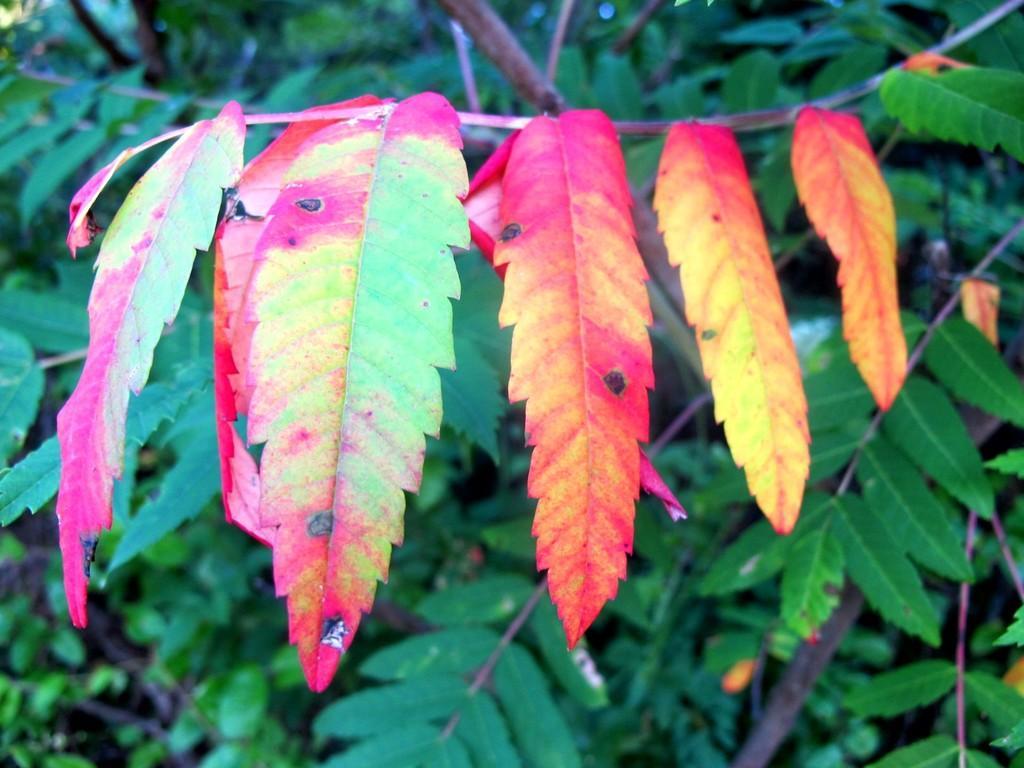Describe this image in one or two sentences. In this picture we can see leaves and tree branches. 